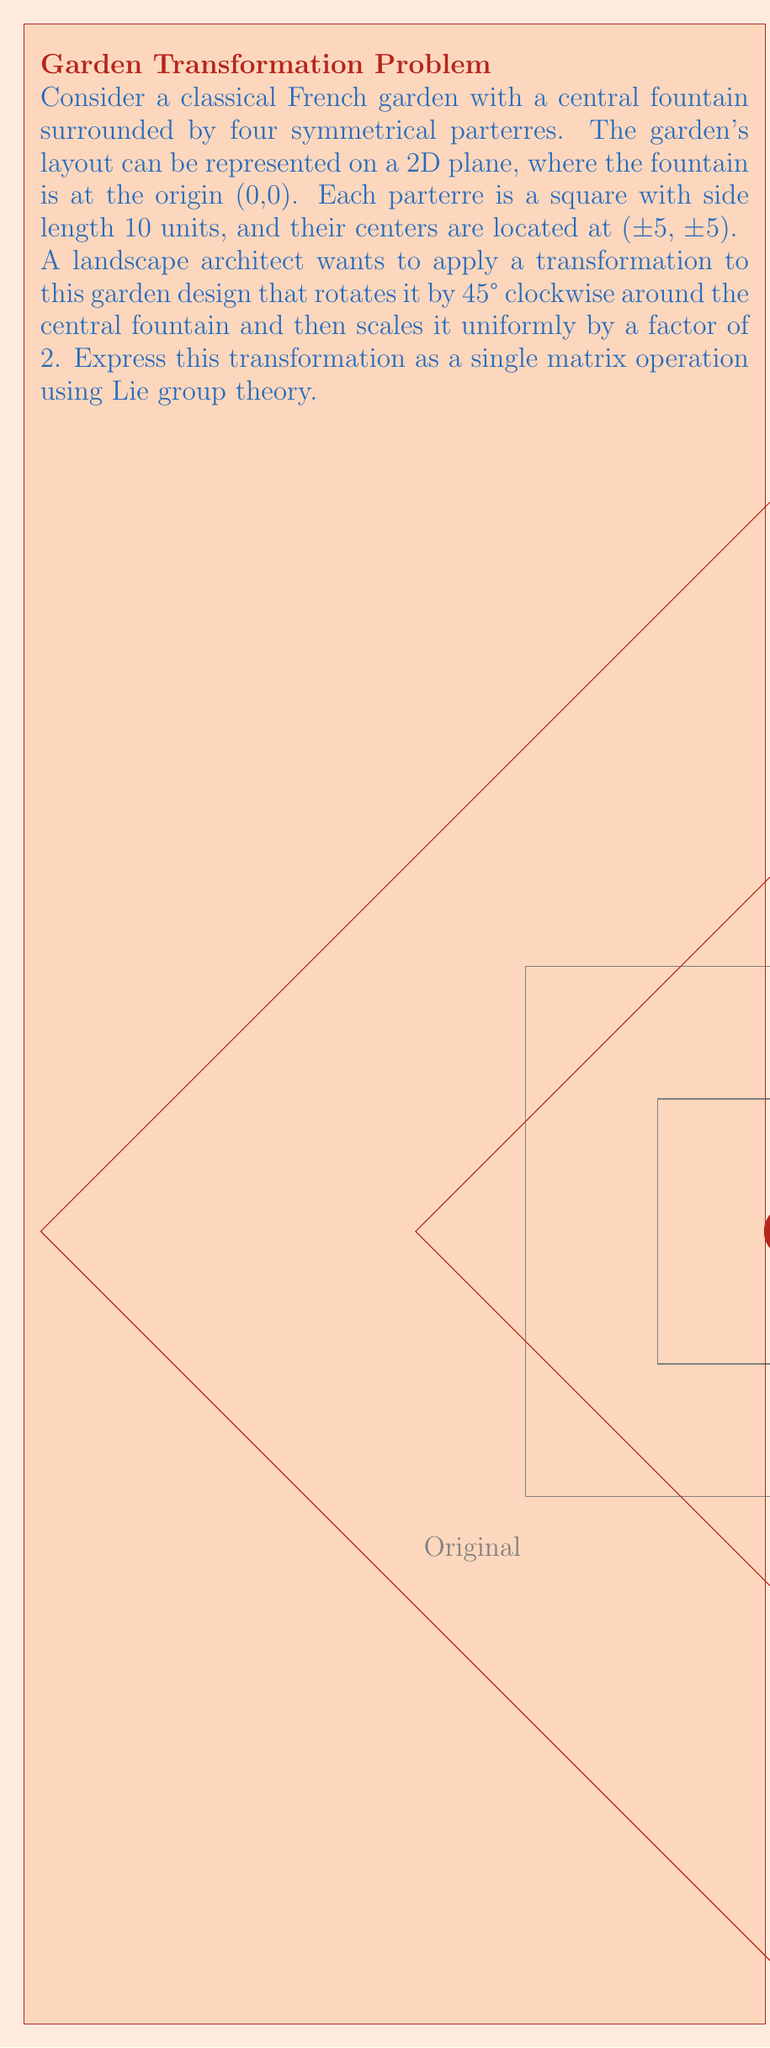Provide a solution to this math problem. Let's approach this step-by-step using Lie group theory:

1) In 2D space, rotations and scaling are elements of the special linear group SL(2,R), which is a Lie group.

2) The rotation matrix for a clockwise rotation by 45° is:
   $$R = \begin{pmatrix} \cos(-45°) & -\sin(-45°) \\ \sin(-45°) & \cos(-45°) \end{pmatrix} = \begin{pmatrix} \frac{\sqrt{2}}{2} & \frac{\sqrt{2}}{2} \\ -\frac{\sqrt{2}}{2} & \frac{\sqrt{2}}{2} \end{pmatrix}$$

3) The scaling matrix for a uniform scale of 2 is:
   $$S = \begin{pmatrix} 2 & 0 \\ 0 & 2 \end{pmatrix}$$

4) In Lie group theory, we can combine these transformations by matrix multiplication. The order matters: we first rotate, then scale. So our combined transformation matrix T is:

   $$T = S \cdot R = \begin{pmatrix} 2 & 0 \\ 0 & 2 \end{pmatrix} \cdot \begin{pmatrix} \frac{\sqrt{2}}{2} & \frac{\sqrt{2}}{2} \\ -\frac{\sqrt{2}}{2} & \frac{\sqrt{2}}{2} \end{pmatrix}$$

5) Multiplying these matrices:

   $$T = \begin{pmatrix} 2 \cdot \frac{\sqrt{2}}{2} & 2 \cdot \frac{\sqrt{2}}{2} \\ -2 \cdot \frac{\sqrt{2}}{2} & 2 \cdot \frac{\sqrt{2}}{2} \end{pmatrix} = \begin{pmatrix} \sqrt{2} & \sqrt{2} \\ -\sqrt{2} & \sqrt{2} \end{pmatrix}$$

This matrix T represents the combined transformation as a single operation in the Lie group SL(2,R).
Answer: $$T = \begin{pmatrix} \sqrt{2} & \sqrt{2} \\ -\sqrt{2} & \sqrt{2} \end{pmatrix}$$ 